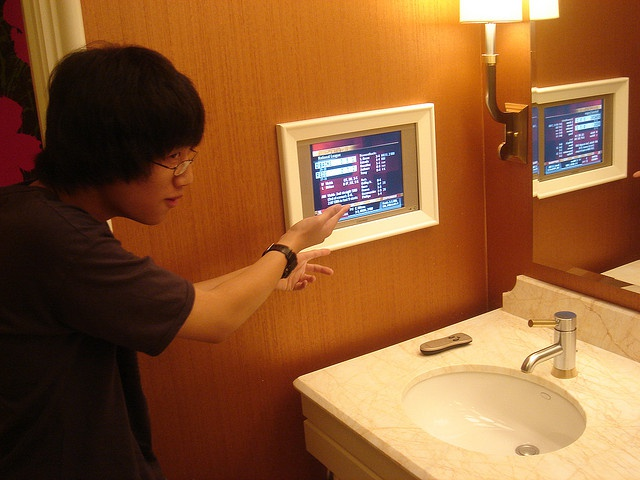Describe the objects in this image and their specific colors. I can see people in black, maroon, brown, and orange tones, sink in black, khaki, tan, and maroon tones, tv in black, tan, white, purple, and olive tones, tv in black, purple, olive, gray, and darkblue tones, and remote in black, tan, maroon, and olive tones in this image. 